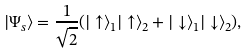Convert formula to latex. <formula><loc_0><loc_0><loc_500><loc_500>| \Psi _ { s } \rangle = \frac { 1 } { \sqrt { 2 } } ( | \uparrow \rangle _ { 1 } | \uparrow \rangle _ { 2 } + | \downarrow \rangle _ { 1 } | \downarrow \rangle _ { 2 } ) ,</formula> 